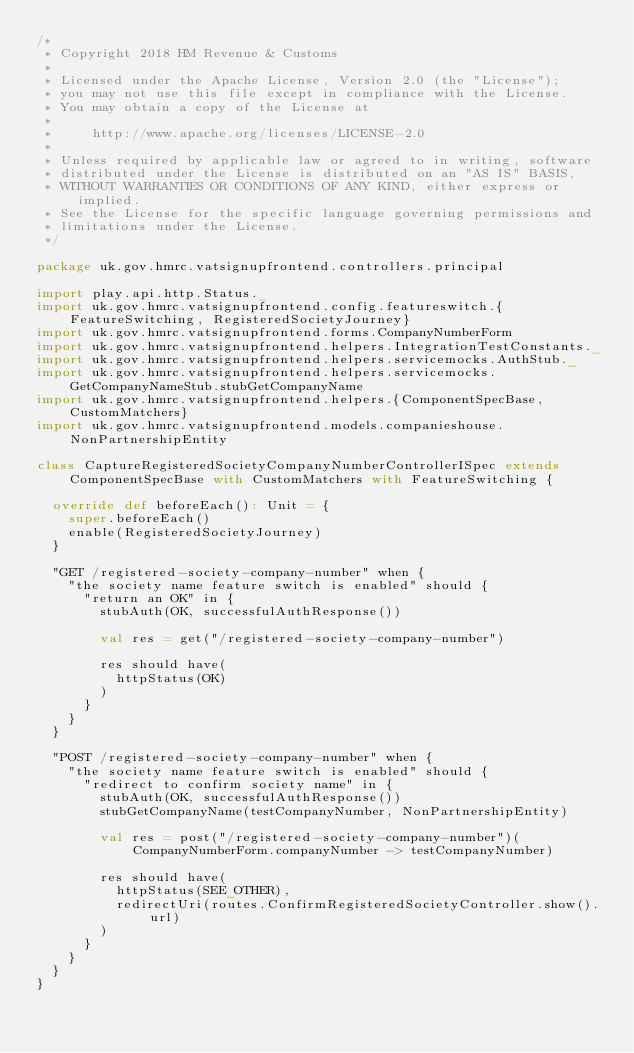Convert code to text. <code><loc_0><loc_0><loc_500><loc_500><_Scala_>/*
 * Copyright 2018 HM Revenue & Customs
 *
 * Licensed under the Apache License, Version 2.0 (the "License");
 * you may not use this file except in compliance with the License.
 * You may obtain a copy of the License at
 *
 *     http://www.apache.org/licenses/LICENSE-2.0
 *
 * Unless required by applicable law or agreed to in writing, software
 * distributed under the License is distributed on an "AS IS" BASIS,
 * WITHOUT WARRANTIES OR CONDITIONS OF ANY KIND, either express or implied.
 * See the License for the specific language governing permissions and
 * limitations under the License.
 */

package uk.gov.hmrc.vatsignupfrontend.controllers.principal

import play.api.http.Status._
import uk.gov.hmrc.vatsignupfrontend.config.featureswitch.{FeatureSwitching, RegisteredSocietyJourney}
import uk.gov.hmrc.vatsignupfrontend.forms.CompanyNumberForm
import uk.gov.hmrc.vatsignupfrontend.helpers.IntegrationTestConstants._
import uk.gov.hmrc.vatsignupfrontend.helpers.servicemocks.AuthStub._
import uk.gov.hmrc.vatsignupfrontend.helpers.servicemocks.GetCompanyNameStub.stubGetCompanyName
import uk.gov.hmrc.vatsignupfrontend.helpers.{ComponentSpecBase, CustomMatchers}
import uk.gov.hmrc.vatsignupfrontend.models.companieshouse.NonPartnershipEntity

class CaptureRegisteredSocietyCompanyNumberControllerISpec extends ComponentSpecBase with CustomMatchers with FeatureSwitching {

  override def beforeEach(): Unit = {
    super.beforeEach()
    enable(RegisteredSocietyJourney)
  }

  "GET /registered-society-company-number" when {
    "the society name feature switch is enabled" should {
      "return an OK" in {
        stubAuth(OK, successfulAuthResponse())

        val res = get("/registered-society-company-number")

        res should have(
          httpStatus(OK)
        )
      }
    }
  }

  "POST /registered-society-company-number" when {
    "the society name feature switch is enabled" should {
      "redirect to confirm society name" in {
        stubAuth(OK, successfulAuthResponse())
        stubGetCompanyName(testCompanyNumber, NonPartnershipEntity)

        val res = post("/registered-society-company-number")(CompanyNumberForm.companyNumber -> testCompanyNumber)

        res should have(
          httpStatus(SEE_OTHER),
          redirectUri(routes.ConfirmRegisteredSocietyController.show().url)
        )
      }
    }
  }
}
</code> 